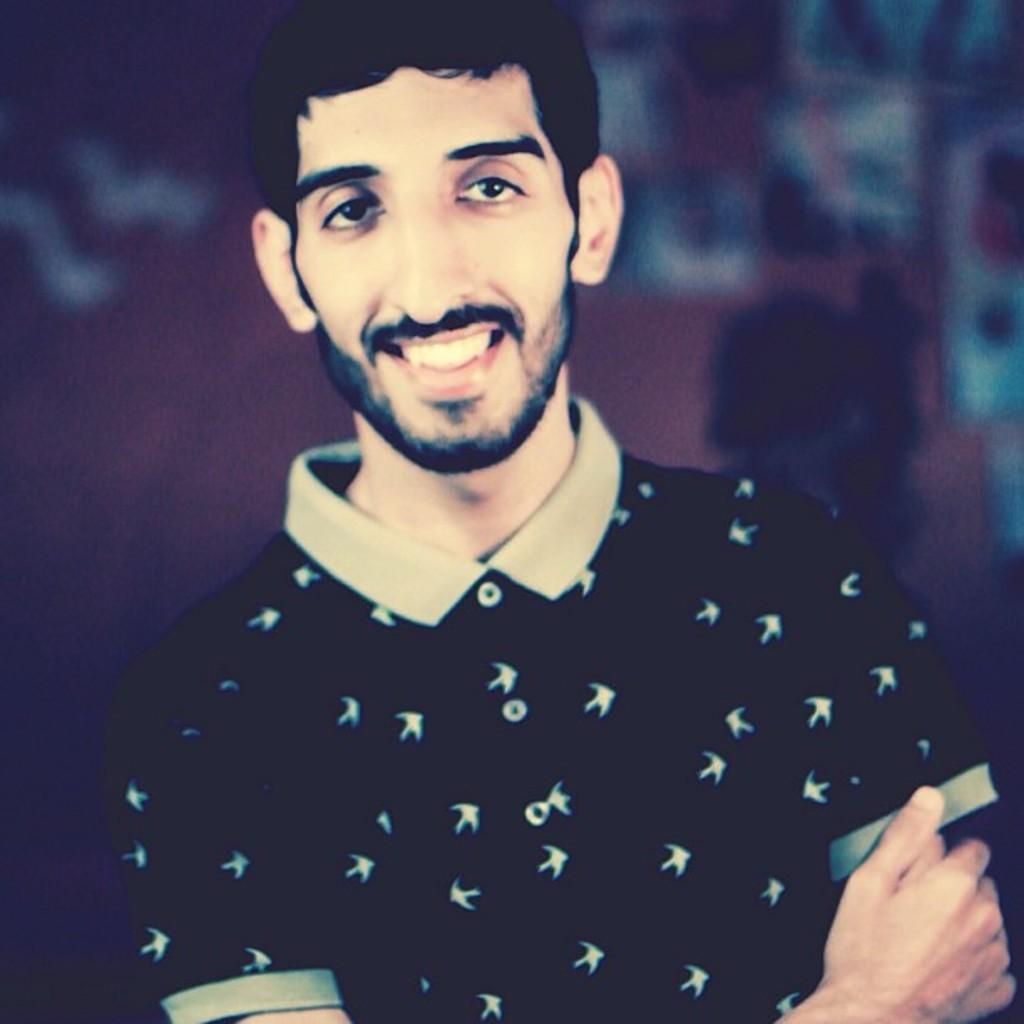What can be seen in the image? There is a person in the image. What is the person wearing? The person is wearing a black color T-shirt. What is the person doing in the image? The person is posing for a photograph. What type of store can be seen in the background of the image? There is no store visible in the image; it only features a person posing for a photograph. What is the person using to draw on the ground in the image? There is no chalk or drawing activity present in the image. 